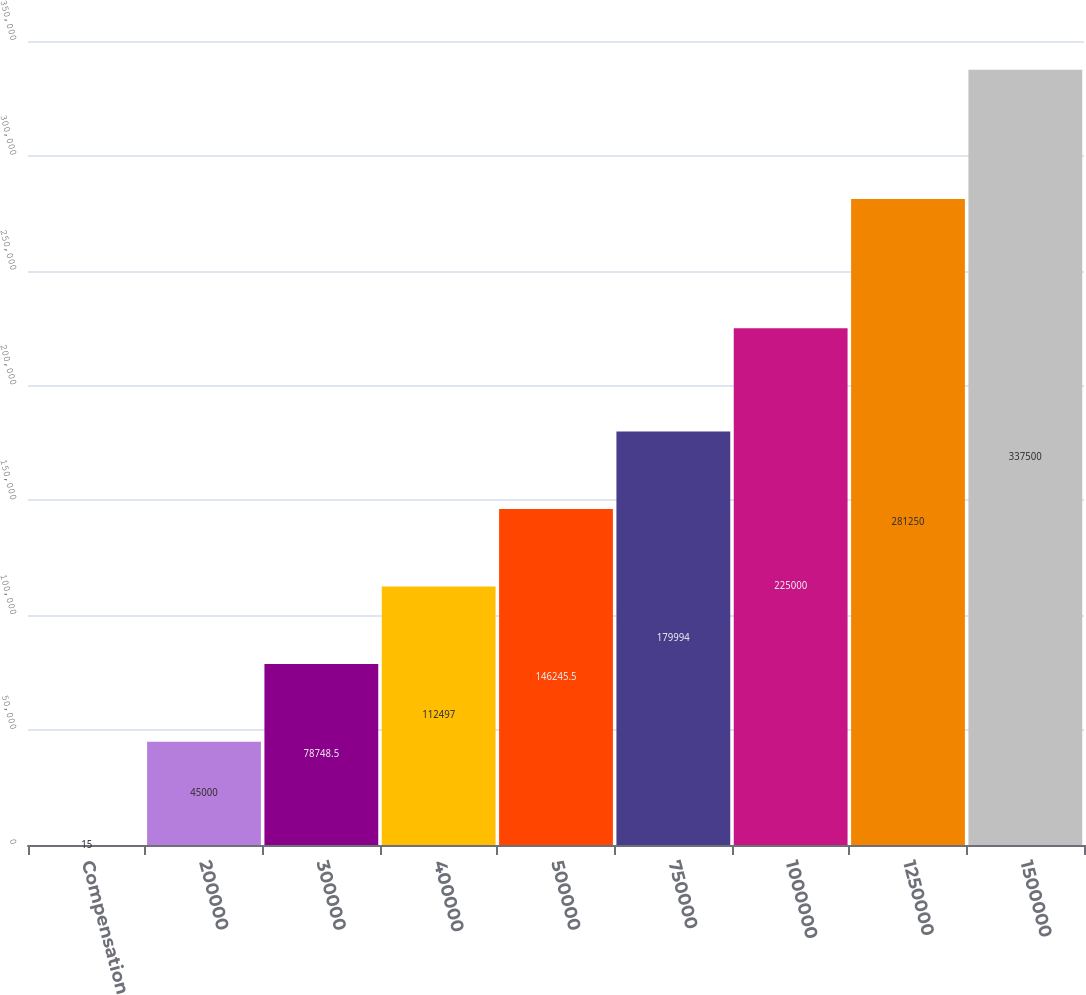Convert chart to OTSL. <chart><loc_0><loc_0><loc_500><loc_500><bar_chart><fcel>Compensation<fcel>200000<fcel>300000<fcel>400000<fcel>500000<fcel>750000<fcel>1000000<fcel>1250000<fcel>1500000<nl><fcel>15<fcel>45000<fcel>78748.5<fcel>112497<fcel>146246<fcel>179994<fcel>225000<fcel>281250<fcel>337500<nl></chart> 